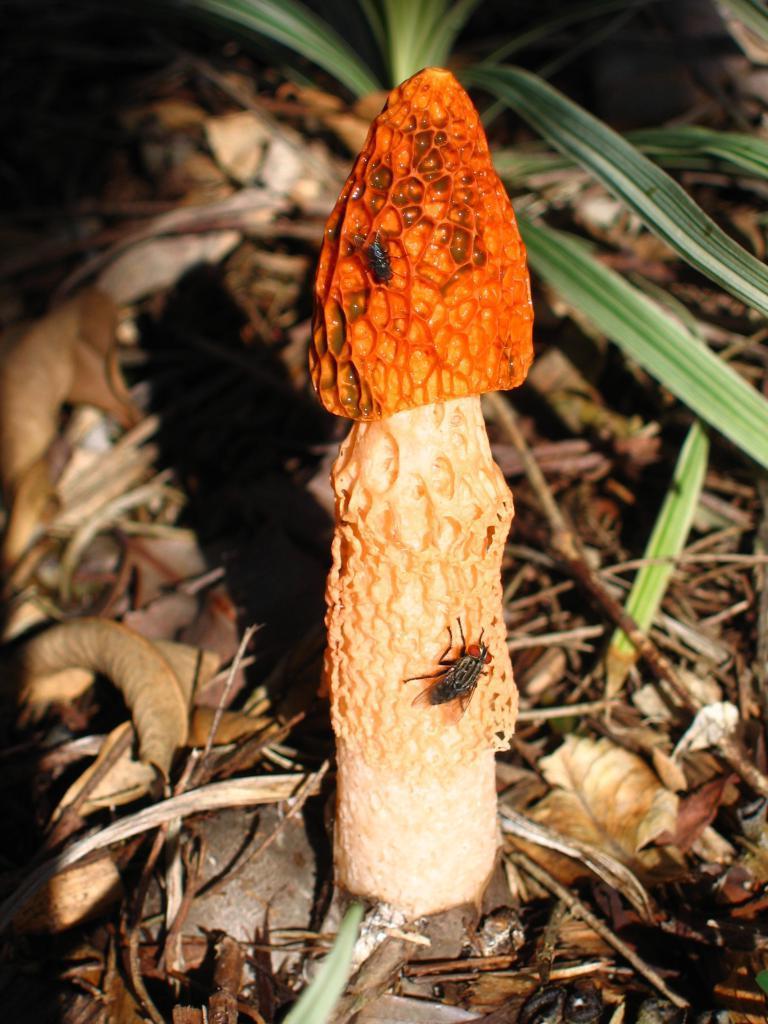In one or two sentences, can you explain what this image depicts? Here in this picture we can see a agaric present on the ground, which is covered with leaves and grass over there and we can see a couple of flies present on it over there. 